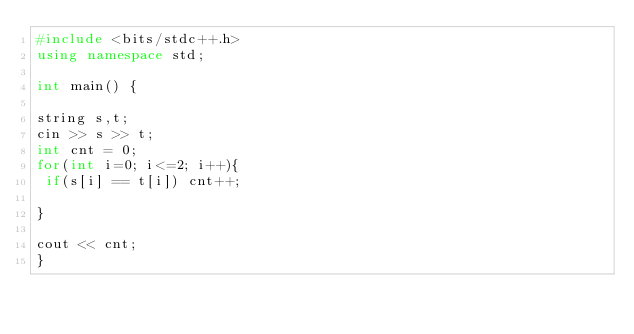Convert code to text. <code><loc_0><loc_0><loc_500><loc_500><_C++_>#include <bits/stdc++.h>
using namespace std;

int main() {

string s,t;
cin >> s >> t;
int cnt = 0;
for(int i=0; i<=2; i++){
 if(s[i] == t[i]) cnt++;
  
}

cout << cnt;
}</code> 